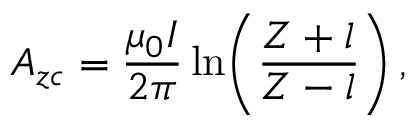<formula> <loc_0><loc_0><loc_500><loc_500>A _ { z c } = \frac { \mu _ { 0 } I } { 2 \pi } \ln \, \left ( \frac { Z + l } { Z - l } \right ) ,</formula> 